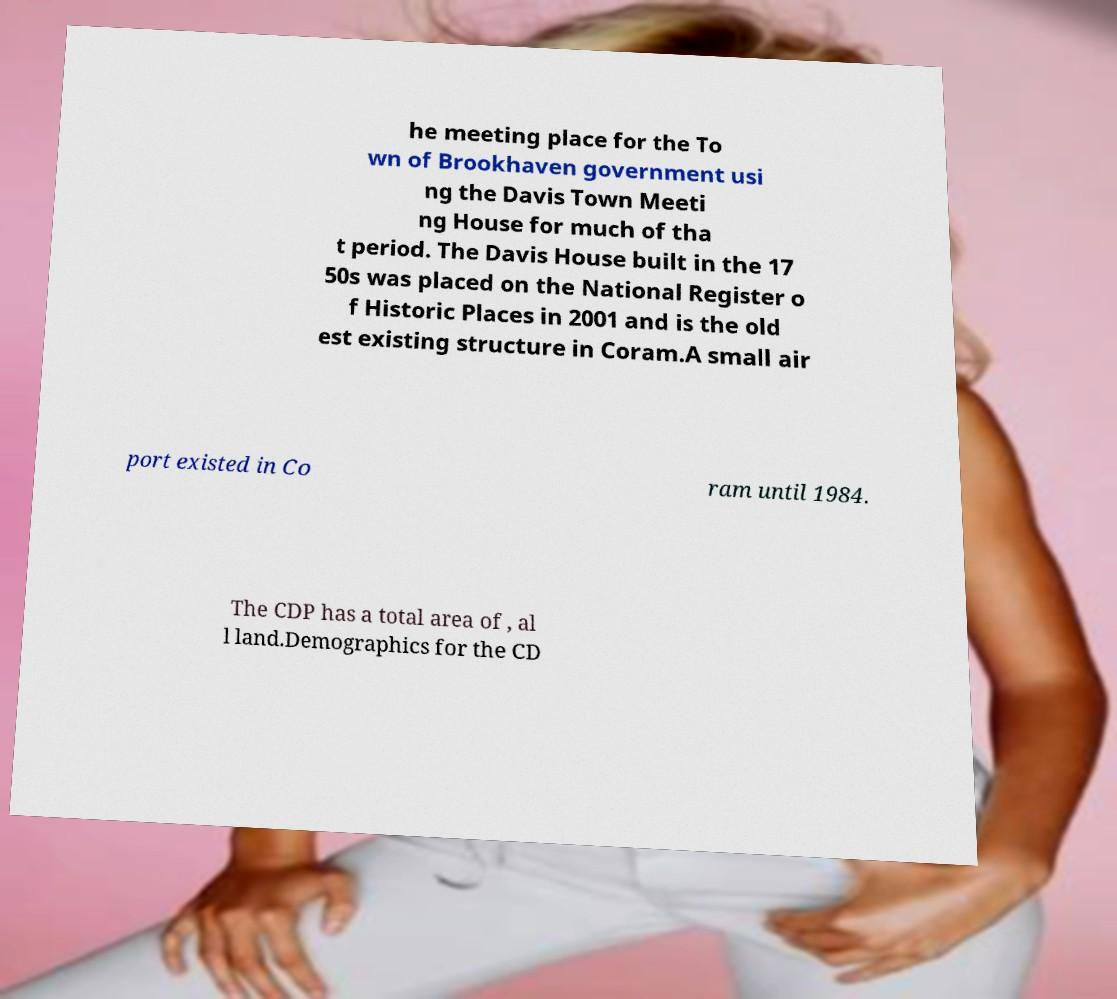Please read and relay the text visible in this image. What does it say? he meeting place for the To wn of Brookhaven government usi ng the Davis Town Meeti ng House for much of tha t period. The Davis House built in the 17 50s was placed on the National Register o f Historic Places in 2001 and is the old est existing structure in Coram.A small air port existed in Co ram until 1984. The CDP has a total area of , al l land.Demographics for the CD 